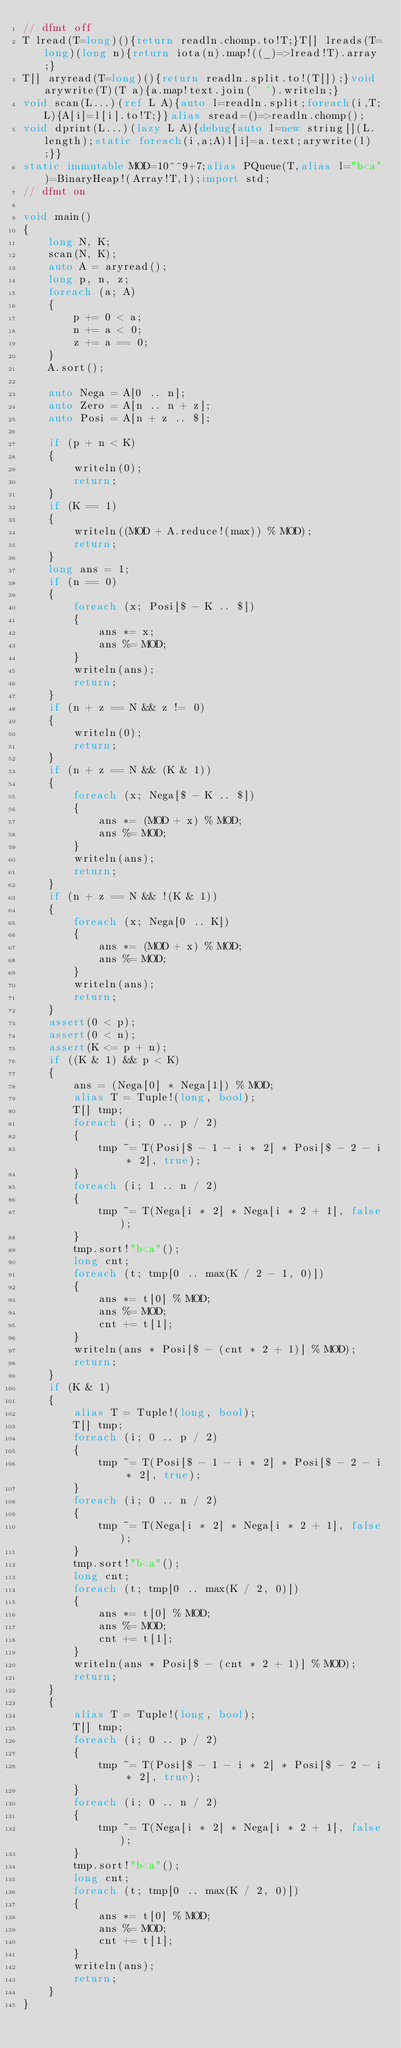<code> <loc_0><loc_0><loc_500><loc_500><_D_>// dfmt off
T lread(T=long)(){return readln.chomp.to!T;}T[] lreads(T=long)(long n){return iota(n).map!((_)=>lread!T).array;}
T[] aryread(T=long)(){return readln.split.to!(T[]);}void arywrite(T)(T a){a.map!text.join(' ').writeln;}
void scan(L...)(ref L A){auto l=readln.split;foreach(i,T;L){A[i]=l[i].to!T;}}alias sread=()=>readln.chomp();
void dprint(L...)(lazy L A){debug{auto l=new string[](L.length);static foreach(i,a;A)l[i]=a.text;arywrite(l);}}
static immutable MOD=10^^9+7;alias PQueue(T,alias l="b<a")=BinaryHeap!(Array!T,l);import std;
// dfmt on

void main()
{
    long N, K;
    scan(N, K);
    auto A = aryread();
    long p, n, z;
    foreach (a; A)
    {
        p += 0 < a;
        n += a < 0;
        z += a == 0;
    }
    A.sort();

    auto Nega = A[0 .. n];
    auto Zero = A[n .. n + z];
    auto Posi = A[n + z .. $];

    if (p + n < K)
    {
        writeln(0);
        return;
    }
    if (K == 1)
    {
        writeln((MOD + A.reduce!(max)) % MOD);
        return;
    }
    long ans = 1;
    if (n == 0)
    {
        foreach (x; Posi[$ - K .. $])
        {
            ans *= x;
            ans %= MOD;
        }
        writeln(ans);
        return;
    }
    if (n + z == N && z != 0)
    {
        writeln(0);
        return;
    }
    if (n + z == N && (K & 1))
    {
        foreach (x; Nega[$ - K .. $])
        {
            ans *= (MOD + x) % MOD;
            ans %= MOD;
        }
        writeln(ans);
        return;
    }
    if (n + z == N && !(K & 1))
    {
        foreach (x; Nega[0 .. K])
        {
            ans *= (MOD + x) % MOD;
            ans %= MOD;
        }
        writeln(ans);
        return;
    }
    assert(0 < p);
    assert(0 < n);
    assert(K <= p + n);
    if ((K & 1) && p < K)
    {
        ans = (Nega[0] * Nega[1]) % MOD;
        alias T = Tuple!(long, bool);
        T[] tmp;
        foreach (i; 0 .. p / 2)
        {
            tmp ~= T(Posi[$ - 1 - i * 2] * Posi[$ - 2 - i * 2], true);
        }
        foreach (i; 1 .. n / 2)
        {
            tmp ~= T(Nega[i * 2] * Nega[i * 2 + 1], false);
        }
        tmp.sort!"b<a"();
        long cnt;
        foreach (t; tmp[0 .. max(K / 2 - 1, 0)])
        {
            ans *= t[0] % MOD;
            ans %= MOD;
            cnt += t[1];
        }
        writeln(ans * Posi[$ - (cnt * 2 + 1)] % MOD);
        return;
    }
    if (K & 1)
    {
        alias T = Tuple!(long, bool);
        T[] tmp;
        foreach (i; 0 .. p / 2)
        {
            tmp ~= T(Posi[$ - 1 - i * 2] * Posi[$ - 2 - i * 2], true);
        }
        foreach (i; 0 .. n / 2)
        {
            tmp ~= T(Nega[i * 2] * Nega[i * 2 + 1], false);
        }
        tmp.sort!"b<a"();
        long cnt;
        foreach (t; tmp[0 .. max(K / 2, 0)])
        {
            ans *= t[0] % MOD;
            ans %= MOD;
            cnt += t[1];
        }
        writeln(ans * Posi[$ - (cnt * 2 + 1)] % MOD);
        return;
    }
    {
        alias T = Tuple!(long, bool);
        T[] tmp;
        foreach (i; 0 .. p / 2)
        {
            tmp ~= T(Posi[$ - 1 - i * 2] * Posi[$ - 2 - i * 2], true);
        }
        foreach (i; 0 .. n / 2)
        {
            tmp ~= T(Nega[i * 2] * Nega[i * 2 + 1], false);
        }
        tmp.sort!"b<a"();
        long cnt;
        foreach (t; tmp[0 .. max(K / 2, 0)])
        {
            ans *= t[0] % MOD;
            ans %= MOD;
            cnt += t[1];
        }
        writeln(ans);
        return;
    }
}
</code> 